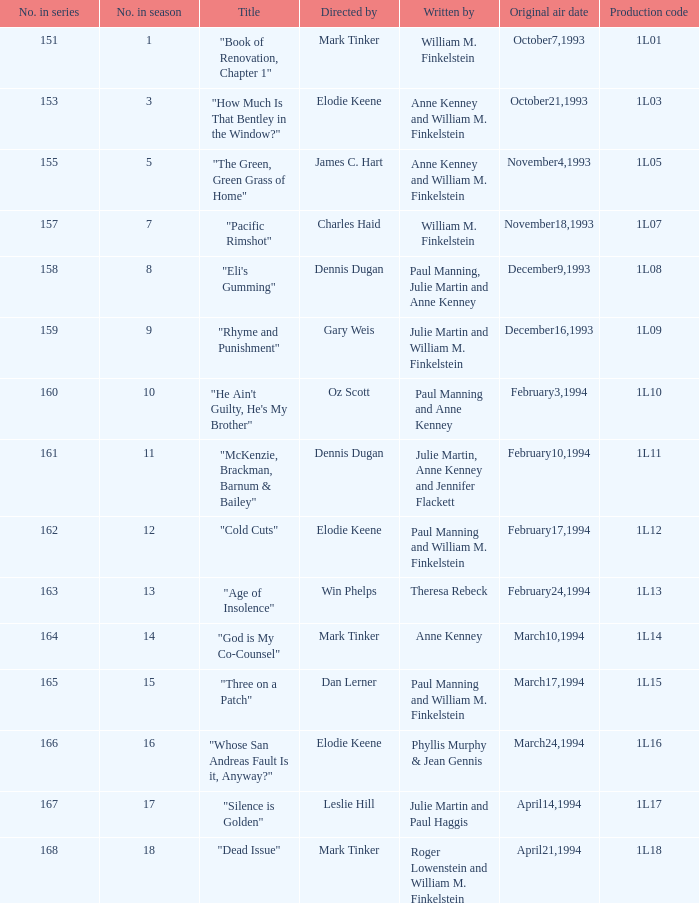Name the original air date for production code 1l16 March24,1994. 